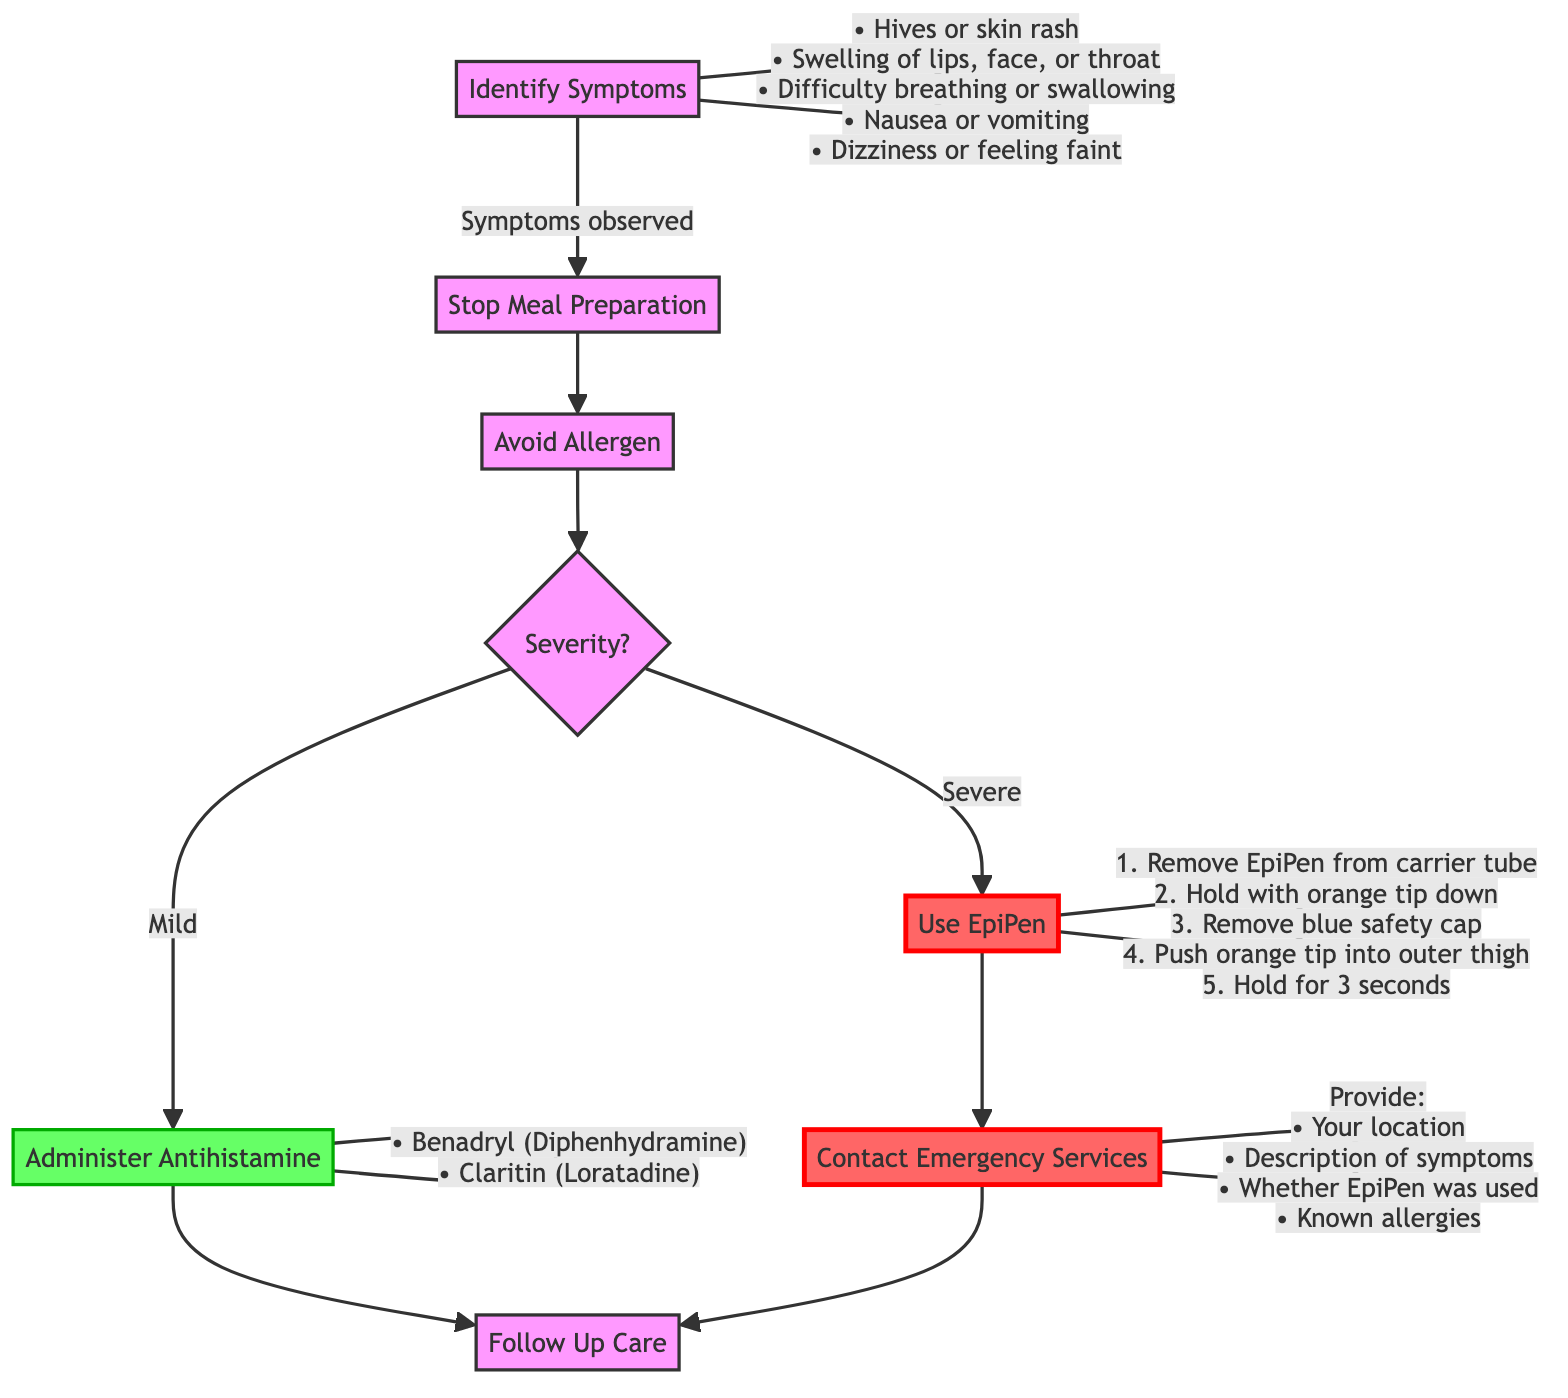What is the first step in the emergency plan? The diagram indicates that the first step is to "Identify Symptoms," which is the initial action to take when dealing with an allergic reaction.
Answer: Identify Symptoms How many symptoms are listed under "Identify Symptoms"? Counting the symptoms provided in the diagram, there are five symptoms listed that one should be vigilant about during an allergic reaction.
Answer: 5 What should you do after stopping meal preparation? According to the flowchart, after stopping meal preparation, the next action is to "Avoid Allergen" to ensure the allergen is removed or avoided.
Answer: Avoid Allergen What action is taken if the reaction is classified as severe? The diagram shows that if the severity of the reaction is deemed severe, the recommended action is to "Use EpiPen" as an immediate response.
Answer: Use EpiPen What information should be provided when contacting emergency services? The flowchart specifies that when contacting emergency services, one should provide their location, description of symptoms, whether an EpiPen was used, and any known allergies.
Answer: Your location, Description of symptoms, Whether EpiPen was used, Any known allergies What is the last step after handling an allergic reaction? The final step illustrated in the diagram is "Follow Up Care" to seek additional advice from an allergist or healthcare provider after the immediate emergency is addressed.
Answer: Follow Up Care What action is taken for mild symptoms? The diagram clearly states that for mild symptoms, the action to take is to "Administer Antihistamine," which could be an over-the-counter medication.
Answer: Administer Antihistamine What should be done immediately after symptoms are identified? Following the identification of symptoms, the very next step according to the flowchart is to "Stop Meal Preparation" to focus on addressing the allergic reaction.
Answer: Stop Meal Preparation What is needed before using the EpiPen? The required action before using the EpiPen is to "Remove the EpiPen from its carrier tube," which is the initial instruction provided in the flowchart for using this device.
Answer: Remove the EpiPen from its carrier tube 